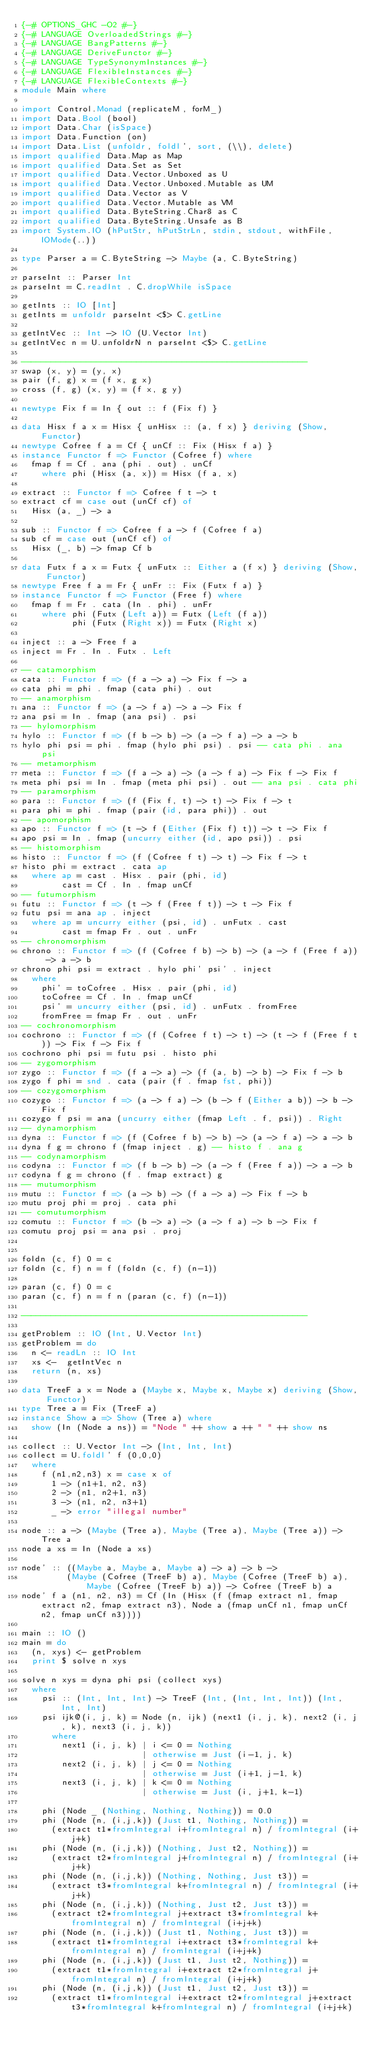Convert code to text. <code><loc_0><loc_0><loc_500><loc_500><_Haskell_>{-# OPTIONS_GHC -O2 #-}
{-# LANGUAGE OverloadedStrings #-}
{-# LANGUAGE BangPatterns #-}
{-# LANGUAGE DeriveFunctor #-}
{-# LANGUAGE TypeSynonymInstances #-}
{-# LANGUAGE FlexibleInstances #-}
{-# LANGUAGE FlexibleContexts #-}
module Main where

import Control.Monad (replicateM, forM_)
import Data.Bool (bool)
import Data.Char (isSpace)
import Data.Function (on)
import Data.List (unfoldr, foldl', sort, (\\), delete)
import qualified Data.Map as Map
import qualified Data.Set as Set
import qualified Data.Vector.Unboxed as U
import qualified Data.Vector.Unboxed.Mutable as UM
import qualified Data.Vector as V
import qualified Data.Vector.Mutable as VM
import qualified Data.ByteString.Char8 as C
import qualified Data.ByteString.Unsafe as B
import System.IO (hPutStr, hPutStrLn, stdin, stdout, withFile, IOMode(..))

type Parser a = C.ByteString -> Maybe (a, C.ByteString)

parseInt :: Parser Int
parseInt = C.readInt . C.dropWhile isSpace

getInts :: IO [Int]
getInts = unfoldr parseInt <$> C.getLine

getIntVec :: Int -> IO (U.Vector Int)
getIntVec n = U.unfoldrN n parseInt <$> C.getLine

---------------------------------------------------------
swap (x, y) = (y, x)
pair (f, g) x = (f x, g x)
cross (f, g) (x, y) = (f x, g y)

newtype Fix f = In { out :: f (Fix f) }

data Hisx f a x = Hisx { unHisx :: (a, f x) } deriving (Show, Functor)
newtype Cofree f a = Cf { unCf :: Fix (Hisx f a) }
instance Functor f => Functor (Cofree f) where
  fmap f = Cf . ana (phi . out) . unCf
    where phi (Hisx (a, x)) = Hisx (f a, x)

extract :: Functor f => Cofree f t -> t
extract cf = case out (unCf cf) of
  Hisx (a, _) -> a

sub :: Functor f => Cofree f a -> f (Cofree f a)
sub cf = case out (unCf cf) of
  Hisx (_, b) -> fmap Cf b

data Futx f a x = Futx { unFutx :: Either a (f x) } deriving (Show, Functor)
newtype Free f a = Fr { unFr :: Fix (Futx f a) }
instance Functor f => Functor (Free f) where
  fmap f = Fr . cata (In . phi) . unFr
    where phi (Futx (Left a)) = Futx (Left (f a))
          phi (Futx (Right x)) = Futx (Right x)

inject :: a -> Free f a
inject = Fr . In . Futx . Left

-- catamorphism
cata :: Functor f => (f a -> a) -> Fix f -> a
cata phi = phi . fmap (cata phi) . out
-- anamorphism
ana :: Functor f => (a -> f a) -> a -> Fix f
ana psi = In . fmap (ana psi) . psi
-- hylomorphism
hylo :: Functor f => (f b -> b) -> (a -> f a) -> a -> b
hylo phi psi = phi . fmap (hylo phi psi) . psi -- cata phi . ana psi
-- metamorphism
meta :: Functor f => (f a -> a) -> (a -> f a) -> Fix f -> Fix f
meta phi psi = In . fmap (meta phi psi) . out -- ana psi . cata phi
-- paramorphism
para :: Functor f => (f (Fix f, t) -> t) -> Fix f -> t
para phi = phi . fmap (pair (id, para phi)) . out
-- apomorphism
apo :: Functor f => (t -> f (Either (Fix f) t)) -> t -> Fix f
apo psi = In . fmap (uncurry either (id, apo psi)) . psi
-- histomorphism
histo :: Functor f => (f (Cofree f t) -> t) -> Fix f -> t
histo phi = extract . cata ap
  where ap = cast . Hisx . pair (phi, id)
        cast = Cf . In . fmap unCf
-- futumorphism
futu :: Functor f => (t -> f (Free f t)) -> t -> Fix f
futu psi = ana ap . inject
  where ap = uncurry either (psi, id) . unFutx . cast
        cast = fmap Fr . out . unFr
-- chronomorphism
chrono :: Functor f => (f (Cofree f b) -> b) -> (a -> f (Free f a)) -> a -> b
chrono phi psi = extract . hylo phi' psi' . inject
  where
    phi' = toCofree . Hisx . pair (phi, id)
    toCofree = Cf . In . fmap unCf
    psi' = uncurry either (psi, id) . unFutx . fromFree
    fromFree = fmap Fr . out . unFr
-- cochronomorphism
cochrono :: Functor f => (f (Cofree f t) -> t) -> (t -> f (Free f t)) -> Fix f -> Fix f
cochrono phi psi = futu psi . histo phi
-- zygomorphism
zygo :: Functor f => (f a -> a) -> (f (a, b) -> b) -> Fix f -> b
zygo f phi = snd . cata (pair (f . fmap fst, phi))
-- cozygomorphism
cozygo :: Functor f => (a -> f a) -> (b -> f (Either a b)) -> b -> Fix f
cozygo f psi = ana (uncurry either (fmap Left . f, psi)) . Right
-- dynamorphism
dyna :: Functor f => (f (Cofree f b) -> b) -> (a -> f a) -> a -> b
dyna f g = chrono f (fmap inject . g) -- histo f . ana g
-- codynamorphism
codyna :: Functor f => (f b -> b) -> (a -> f (Free f a)) -> a -> b
codyna f g = chrono (f . fmap extract) g
-- mutumorphism
mutu :: Functor f => (a -> b) -> (f a -> a) -> Fix f -> b
mutu proj phi = proj . cata phi
-- comutumorphism
comutu :: Functor f => (b -> a) -> (a -> f a) -> b -> Fix f
comutu proj psi = ana psi . proj


foldn (c, f) 0 = c
foldn (c, f) n = f (foldn (c, f) (n-1))

paran (c, f) 0 = c
paran (c, f) n = f n (paran (c, f) (n-1))

---------------------------------------------------------

getProblem :: IO (Int, U.Vector Int)
getProblem = do
  n <- readLn :: IO Int
  xs <-  getIntVec n
  return (n, xs)

data TreeF a x = Node a (Maybe x, Maybe x, Maybe x) deriving (Show, Functor)
type Tree a = Fix (TreeF a)
instance Show a => Show (Tree a) where
  show (In (Node a ns)) = "Node " ++ show a ++ " " ++ show ns

collect :: U.Vector Int -> (Int, Int, Int)
collect = U.foldl' f (0,0,0)
  where
    f (n1,n2,n3) x = case x of
      1 -> (n1+1, n2, n3)
      2 -> (n1, n2+1, n3)
      3 -> (n1, n2, n3+1)
      _ -> error "illegal number"

node :: a -> (Maybe (Tree a), Maybe (Tree a), Maybe (Tree a)) -> Tree a
node a xs = In (Node a xs)

node' :: ((Maybe a, Maybe a, Maybe a) -> a) -> b ->
         (Maybe (Cofree (TreeF b) a), Maybe (Cofree (TreeF b) a), Maybe (Cofree (TreeF b) a)) -> Cofree (TreeF b) a
node' f a (n1, n2, n3) = Cf (In (Hisx (f (fmap extract n1, fmap extract n2, fmap extract n3), Node a (fmap unCf n1, fmap unCf n2, fmap unCf n3))))

main :: IO ()
main = do
  (n, xys) <- getProblem
  print $ solve n xys

solve n xys = dyna phi psi (collect xys)
  where
    psi :: (Int, Int, Int) -> TreeF (Int, (Int, Int, Int)) (Int, Int, Int)
    psi ijk@(i, j, k) = Node (n, ijk) (next1 (i, j, k), next2 (i, j, k), next3 (i, j, k))
      where
        next1 (i, j, k) | i <= 0 = Nothing
                        | otherwise = Just (i-1, j, k)
        next2 (i, j, k) | j <= 0 = Nothing
                        | otherwise = Just (i+1, j-1, k)
        next3 (i, j, k) | k <= 0 = Nothing
                        | otherwise = Just (i, j+1, k-1)

    phi (Node _ (Nothing, Nothing, Nothing)) = 0.0
    phi (Node (n, (i,j,k)) (Just t1, Nothing, Nothing)) =
      (extract t1*fromIntegral i+fromIntegral n) / fromIntegral (i+j+k)
    phi (Node (n, (i,j,k)) (Nothing, Just t2, Nothing)) =
      (extract t2*fromIntegral j+fromIntegral n) / fromIntegral (i+j+k)
    phi (Node (n, (i,j,k)) (Nothing, Nothing, Just t3)) =
      (extract t3*fromIntegral k+fromIntegral n) / fromIntegral (i+j+k)
    phi (Node (n, (i,j,k)) (Nothing, Just t2, Just t3)) =
      (extract t2*fromIntegral j+extract t3*fromIntegral k+fromIntegral n) / fromIntegral (i+j+k)
    phi (Node (n, (i,j,k)) (Just t1, Nothing, Just t3)) =
      (extract t1*fromIntegral i+extract t3*fromIntegral k+fromIntegral n) / fromIntegral (i+j+k)
    phi (Node (n, (i,j,k)) (Just t1, Just t2, Nothing)) =
      (extract t1*fromIntegral i+extract t2*fromIntegral j+fromIntegral n) / fromIntegral (i+j+k)
    phi (Node (n, (i,j,k)) (Just t1, Just t2, Just t3)) =
      (extract t1*fromIntegral i+extract t2*fromIntegral j+extract t3*fromIntegral k+fromIntegral n) / fromIntegral (i+j+k)
</code> 